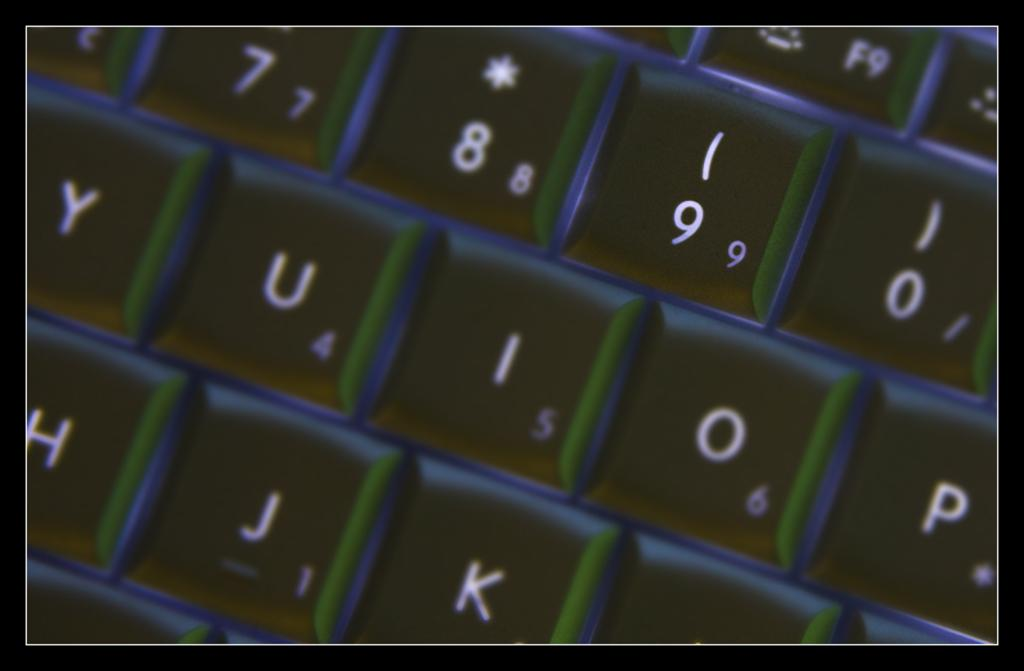<image>
Provide a brief description of the given image. An up close look at a keyboard; the close up view is off the 7,8,9,0 and many letter keys 